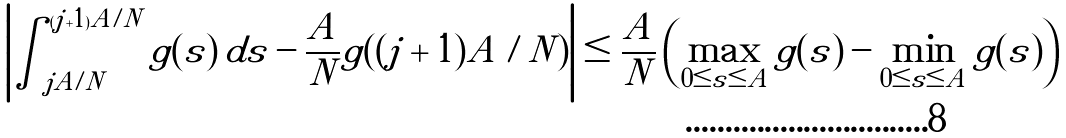<formula> <loc_0><loc_0><loc_500><loc_500>\left | \int _ { j A / N } ^ { ( j + 1 ) A / N } g ( s ) \, d s - \frac { A } { N } g ( ( j + 1 ) A / N ) \right | \leq \frac { A } { N } \left ( \max _ { 0 \leq { s } \leq { A } } { g ( s ) } - \min _ { 0 \leq { s } \leq { A } } { g ( s ) } \right )</formula> 